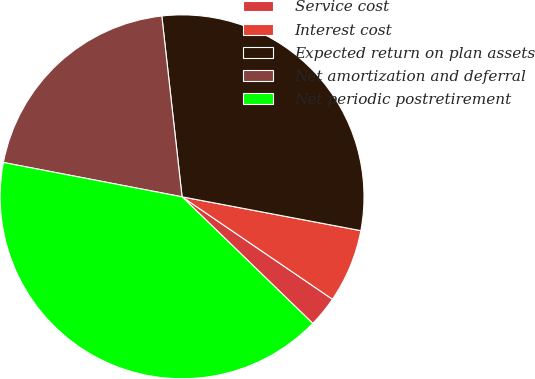<chart> <loc_0><loc_0><loc_500><loc_500><pie_chart><fcel>Service cost<fcel>Interest cost<fcel>Expected return on plan assets<fcel>Net amortization and deferral<fcel>Net periodic postretirement<nl><fcel>2.73%<fcel>6.54%<fcel>29.75%<fcel>20.2%<fcel>40.77%<nl></chart> 